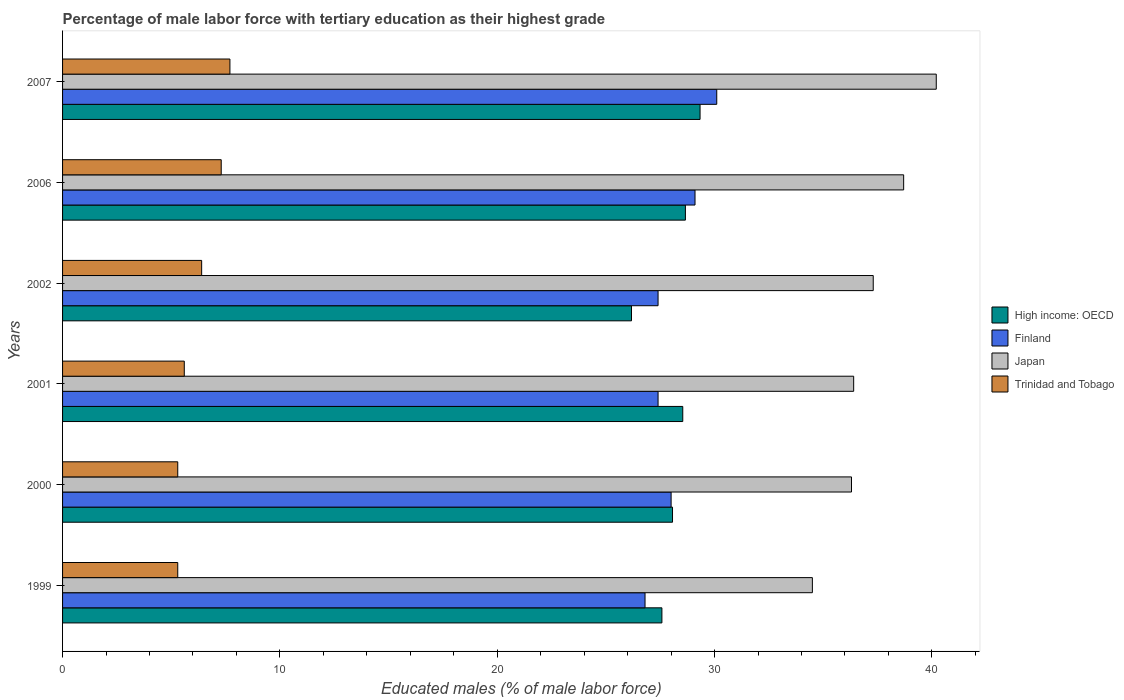How many different coloured bars are there?
Provide a succinct answer. 4. How many groups of bars are there?
Your answer should be very brief. 6. Are the number of bars per tick equal to the number of legend labels?
Ensure brevity in your answer.  Yes. How many bars are there on the 2nd tick from the top?
Offer a terse response. 4. In how many cases, is the number of bars for a given year not equal to the number of legend labels?
Your answer should be very brief. 0. What is the percentage of male labor force with tertiary education in High income: OECD in 2007?
Your answer should be compact. 29.33. Across all years, what is the maximum percentage of male labor force with tertiary education in Finland?
Provide a succinct answer. 30.1. Across all years, what is the minimum percentage of male labor force with tertiary education in Finland?
Keep it short and to the point. 26.8. In which year was the percentage of male labor force with tertiary education in Trinidad and Tobago minimum?
Your answer should be very brief. 1999. What is the total percentage of male labor force with tertiary education in Finland in the graph?
Your answer should be compact. 168.8. What is the difference between the percentage of male labor force with tertiary education in Japan in 2007 and the percentage of male labor force with tertiary education in Trinidad and Tobago in 2002?
Provide a short and direct response. 33.8. What is the average percentage of male labor force with tertiary education in High income: OECD per year?
Ensure brevity in your answer.  28.06. In the year 2002, what is the difference between the percentage of male labor force with tertiary education in Trinidad and Tobago and percentage of male labor force with tertiary education in Finland?
Give a very brief answer. -21. What is the ratio of the percentage of male labor force with tertiary education in High income: OECD in 1999 to that in 2001?
Make the answer very short. 0.97. Is the difference between the percentage of male labor force with tertiary education in Trinidad and Tobago in 2000 and 2006 greater than the difference between the percentage of male labor force with tertiary education in Finland in 2000 and 2006?
Your answer should be very brief. No. What is the difference between the highest and the lowest percentage of male labor force with tertiary education in High income: OECD?
Your response must be concise. 3.15. In how many years, is the percentage of male labor force with tertiary education in Finland greater than the average percentage of male labor force with tertiary education in Finland taken over all years?
Your answer should be very brief. 2. Is it the case that in every year, the sum of the percentage of male labor force with tertiary education in Finland and percentage of male labor force with tertiary education in High income: OECD is greater than the sum of percentage of male labor force with tertiary education in Trinidad and Tobago and percentage of male labor force with tertiary education in Japan?
Offer a very short reply. No. What does the 4th bar from the top in 2000 represents?
Ensure brevity in your answer.  High income: OECD. How many bars are there?
Provide a short and direct response. 24. How many years are there in the graph?
Your response must be concise. 6. Does the graph contain grids?
Provide a succinct answer. No. What is the title of the graph?
Your answer should be compact. Percentage of male labor force with tertiary education as their highest grade. What is the label or title of the X-axis?
Offer a terse response. Educated males (% of male labor force). What is the label or title of the Y-axis?
Offer a terse response. Years. What is the Educated males (% of male labor force) in High income: OECD in 1999?
Provide a succinct answer. 27.58. What is the Educated males (% of male labor force) of Finland in 1999?
Provide a succinct answer. 26.8. What is the Educated males (% of male labor force) of Japan in 1999?
Offer a terse response. 34.5. What is the Educated males (% of male labor force) of Trinidad and Tobago in 1999?
Ensure brevity in your answer.  5.3. What is the Educated males (% of male labor force) in High income: OECD in 2000?
Offer a terse response. 28.06. What is the Educated males (% of male labor force) in Finland in 2000?
Give a very brief answer. 28. What is the Educated males (% of male labor force) in Japan in 2000?
Provide a succinct answer. 36.3. What is the Educated males (% of male labor force) of Trinidad and Tobago in 2000?
Offer a terse response. 5.3. What is the Educated males (% of male labor force) of High income: OECD in 2001?
Keep it short and to the point. 28.54. What is the Educated males (% of male labor force) in Finland in 2001?
Make the answer very short. 27.4. What is the Educated males (% of male labor force) in Japan in 2001?
Give a very brief answer. 36.4. What is the Educated males (% of male labor force) of Trinidad and Tobago in 2001?
Make the answer very short. 5.6. What is the Educated males (% of male labor force) in High income: OECD in 2002?
Provide a succinct answer. 26.18. What is the Educated males (% of male labor force) of Finland in 2002?
Your response must be concise. 27.4. What is the Educated males (% of male labor force) in Japan in 2002?
Make the answer very short. 37.3. What is the Educated males (% of male labor force) in Trinidad and Tobago in 2002?
Ensure brevity in your answer.  6.4. What is the Educated males (% of male labor force) of High income: OECD in 2006?
Provide a succinct answer. 28.66. What is the Educated males (% of male labor force) in Finland in 2006?
Your response must be concise. 29.1. What is the Educated males (% of male labor force) of Japan in 2006?
Your response must be concise. 38.7. What is the Educated males (% of male labor force) of Trinidad and Tobago in 2006?
Offer a very short reply. 7.3. What is the Educated males (% of male labor force) of High income: OECD in 2007?
Make the answer very short. 29.33. What is the Educated males (% of male labor force) of Finland in 2007?
Offer a terse response. 30.1. What is the Educated males (% of male labor force) of Japan in 2007?
Offer a very short reply. 40.2. What is the Educated males (% of male labor force) in Trinidad and Tobago in 2007?
Your answer should be very brief. 7.7. Across all years, what is the maximum Educated males (% of male labor force) of High income: OECD?
Your response must be concise. 29.33. Across all years, what is the maximum Educated males (% of male labor force) of Finland?
Provide a succinct answer. 30.1. Across all years, what is the maximum Educated males (% of male labor force) of Japan?
Make the answer very short. 40.2. Across all years, what is the maximum Educated males (% of male labor force) of Trinidad and Tobago?
Your answer should be compact. 7.7. Across all years, what is the minimum Educated males (% of male labor force) of High income: OECD?
Your response must be concise. 26.18. Across all years, what is the minimum Educated males (% of male labor force) of Finland?
Keep it short and to the point. 26.8. Across all years, what is the minimum Educated males (% of male labor force) in Japan?
Give a very brief answer. 34.5. Across all years, what is the minimum Educated males (% of male labor force) in Trinidad and Tobago?
Your answer should be very brief. 5.3. What is the total Educated males (% of male labor force) in High income: OECD in the graph?
Provide a succinct answer. 168.34. What is the total Educated males (% of male labor force) of Finland in the graph?
Make the answer very short. 168.8. What is the total Educated males (% of male labor force) of Japan in the graph?
Provide a short and direct response. 223.4. What is the total Educated males (% of male labor force) of Trinidad and Tobago in the graph?
Your answer should be very brief. 37.6. What is the difference between the Educated males (% of male labor force) in High income: OECD in 1999 and that in 2000?
Provide a short and direct response. -0.49. What is the difference between the Educated males (% of male labor force) of Finland in 1999 and that in 2000?
Give a very brief answer. -1.2. What is the difference between the Educated males (% of male labor force) in Japan in 1999 and that in 2000?
Your answer should be compact. -1.8. What is the difference between the Educated males (% of male labor force) in High income: OECD in 1999 and that in 2001?
Provide a short and direct response. -0.96. What is the difference between the Educated males (% of male labor force) in Japan in 1999 and that in 2001?
Offer a terse response. -1.9. What is the difference between the Educated males (% of male labor force) in Trinidad and Tobago in 1999 and that in 2001?
Ensure brevity in your answer.  -0.3. What is the difference between the Educated males (% of male labor force) in High income: OECD in 1999 and that in 2002?
Provide a short and direct response. 1.4. What is the difference between the Educated males (% of male labor force) in Japan in 1999 and that in 2002?
Offer a very short reply. -2.8. What is the difference between the Educated males (% of male labor force) of Trinidad and Tobago in 1999 and that in 2002?
Give a very brief answer. -1.1. What is the difference between the Educated males (% of male labor force) in High income: OECD in 1999 and that in 2006?
Your response must be concise. -1.08. What is the difference between the Educated males (% of male labor force) of Finland in 1999 and that in 2006?
Keep it short and to the point. -2.3. What is the difference between the Educated males (% of male labor force) in Japan in 1999 and that in 2006?
Ensure brevity in your answer.  -4.2. What is the difference between the Educated males (% of male labor force) of High income: OECD in 1999 and that in 2007?
Provide a succinct answer. -1.76. What is the difference between the Educated males (% of male labor force) in Finland in 1999 and that in 2007?
Provide a short and direct response. -3.3. What is the difference between the Educated males (% of male labor force) of Japan in 1999 and that in 2007?
Offer a very short reply. -5.7. What is the difference between the Educated males (% of male labor force) of Trinidad and Tobago in 1999 and that in 2007?
Make the answer very short. -2.4. What is the difference between the Educated males (% of male labor force) in High income: OECD in 2000 and that in 2001?
Give a very brief answer. -0.47. What is the difference between the Educated males (% of male labor force) of Finland in 2000 and that in 2001?
Your answer should be compact. 0.6. What is the difference between the Educated males (% of male labor force) in Japan in 2000 and that in 2001?
Offer a very short reply. -0.1. What is the difference between the Educated males (% of male labor force) in Trinidad and Tobago in 2000 and that in 2001?
Make the answer very short. -0.3. What is the difference between the Educated males (% of male labor force) in High income: OECD in 2000 and that in 2002?
Ensure brevity in your answer.  1.89. What is the difference between the Educated males (% of male labor force) in Japan in 2000 and that in 2002?
Your answer should be compact. -1. What is the difference between the Educated males (% of male labor force) in High income: OECD in 2000 and that in 2006?
Your response must be concise. -0.59. What is the difference between the Educated males (% of male labor force) in Finland in 2000 and that in 2006?
Your answer should be compact. -1.1. What is the difference between the Educated males (% of male labor force) in Japan in 2000 and that in 2006?
Offer a terse response. -2.4. What is the difference between the Educated males (% of male labor force) of Trinidad and Tobago in 2000 and that in 2006?
Make the answer very short. -2. What is the difference between the Educated males (% of male labor force) in High income: OECD in 2000 and that in 2007?
Your answer should be compact. -1.27. What is the difference between the Educated males (% of male labor force) in Trinidad and Tobago in 2000 and that in 2007?
Your answer should be very brief. -2.4. What is the difference between the Educated males (% of male labor force) of High income: OECD in 2001 and that in 2002?
Offer a very short reply. 2.36. What is the difference between the Educated males (% of male labor force) in Finland in 2001 and that in 2002?
Make the answer very short. 0. What is the difference between the Educated males (% of male labor force) of Trinidad and Tobago in 2001 and that in 2002?
Keep it short and to the point. -0.8. What is the difference between the Educated males (% of male labor force) in High income: OECD in 2001 and that in 2006?
Give a very brief answer. -0.12. What is the difference between the Educated males (% of male labor force) in Finland in 2001 and that in 2006?
Offer a very short reply. -1.7. What is the difference between the Educated males (% of male labor force) in Japan in 2001 and that in 2006?
Provide a succinct answer. -2.3. What is the difference between the Educated males (% of male labor force) of Trinidad and Tobago in 2001 and that in 2006?
Offer a very short reply. -1.7. What is the difference between the Educated males (% of male labor force) in High income: OECD in 2001 and that in 2007?
Keep it short and to the point. -0.8. What is the difference between the Educated males (% of male labor force) in Finland in 2001 and that in 2007?
Your answer should be compact. -2.7. What is the difference between the Educated males (% of male labor force) in Trinidad and Tobago in 2001 and that in 2007?
Provide a succinct answer. -2.1. What is the difference between the Educated males (% of male labor force) in High income: OECD in 2002 and that in 2006?
Offer a very short reply. -2.48. What is the difference between the Educated males (% of male labor force) in Finland in 2002 and that in 2006?
Your answer should be compact. -1.7. What is the difference between the Educated males (% of male labor force) of Japan in 2002 and that in 2006?
Give a very brief answer. -1.4. What is the difference between the Educated males (% of male labor force) of High income: OECD in 2002 and that in 2007?
Your answer should be compact. -3.15. What is the difference between the Educated males (% of male labor force) in Trinidad and Tobago in 2002 and that in 2007?
Provide a short and direct response. -1.3. What is the difference between the Educated males (% of male labor force) of High income: OECD in 2006 and that in 2007?
Give a very brief answer. -0.67. What is the difference between the Educated males (% of male labor force) in Japan in 2006 and that in 2007?
Your answer should be very brief. -1.5. What is the difference between the Educated males (% of male labor force) in High income: OECD in 1999 and the Educated males (% of male labor force) in Finland in 2000?
Keep it short and to the point. -0.42. What is the difference between the Educated males (% of male labor force) in High income: OECD in 1999 and the Educated males (% of male labor force) in Japan in 2000?
Provide a short and direct response. -8.72. What is the difference between the Educated males (% of male labor force) in High income: OECD in 1999 and the Educated males (% of male labor force) in Trinidad and Tobago in 2000?
Keep it short and to the point. 22.28. What is the difference between the Educated males (% of male labor force) of Finland in 1999 and the Educated males (% of male labor force) of Trinidad and Tobago in 2000?
Provide a short and direct response. 21.5. What is the difference between the Educated males (% of male labor force) of Japan in 1999 and the Educated males (% of male labor force) of Trinidad and Tobago in 2000?
Provide a short and direct response. 29.2. What is the difference between the Educated males (% of male labor force) in High income: OECD in 1999 and the Educated males (% of male labor force) in Finland in 2001?
Provide a short and direct response. 0.18. What is the difference between the Educated males (% of male labor force) in High income: OECD in 1999 and the Educated males (% of male labor force) in Japan in 2001?
Give a very brief answer. -8.82. What is the difference between the Educated males (% of male labor force) of High income: OECD in 1999 and the Educated males (% of male labor force) of Trinidad and Tobago in 2001?
Your answer should be very brief. 21.98. What is the difference between the Educated males (% of male labor force) of Finland in 1999 and the Educated males (% of male labor force) of Japan in 2001?
Provide a short and direct response. -9.6. What is the difference between the Educated males (% of male labor force) in Finland in 1999 and the Educated males (% of male labor force) in Trinidad and Tobago in 2001?
Ensure brevity in your answer.  21.2. What is the difference between the Educated males (% of male labor force) of Japan in 1999 and the Educated males (% of male labor force) of Trinidad and Tobago in 2001?
Give a very brief answer. 28.9. What is the difference between the Educated males (% of male labor force) of High income: OECD in 1999 and the Educated males (% of male labor force) of Finland in 2002?
Your answer should be compact. 0.18. What is the difference between the Educated males (% of male labor force) of High income: OECD in 1999 and the Educated males (% of male labor force) of Japan in 2002?
Your answer should be very brief. -9.72. What is the difference between the Educated males (% of male labor force) in High income: OECD in 1999 and the Educated males (% of male labor force) in Trinidad and Tobago in 2002?
Ensure brevity in your answer.  21.18. What is the difference between the Educated males (% of male labor force) of Finland in 1999 and the Educated males (% of male labor force) of Japan in 2002?
Give a very brief answer. -10.5. What is the difference between the Educated males (% of male labor force) of Finland in 1999 and the Educated males (% of male labor force) of Trinidad and Tobago in 2002?
Provide a short and direct response. 20.4. What is the difference between the Educated males (% of male labor force) of Japan in 1999 and the Educated males (% of male labor force) of Trinidad and Tobago in 2002?
Provide a short and direct response. 28.1. What is the difference between the Educated males (% of male labor force) of High income: OECD in 1999 and the Educated males (% of male labor force) of Finland in 2006?
Offer a very short reply. -1.52. What is the difference between the Educated males (% of male labor force) of High income: OECD in 1999 and the Educated males (% of male labor force) of Japan in 2006?
Your response must be concise. -11.12. What is the difference between the Educated males (% of male labor force) in High income: OECD in 1999 and the Educated males (% of male labor force) in Trinidad and Tobago in 2006?
Provide a succinct answer. 20.28. What is the difference between the Educated males (% of male labor force) in Finland in 1999 and the Educated males (% of male labor force) in Japan in 2006?
Provide a short and direct response. -11.9. What is the difference between the Educated males (% of male labor force) of Japan in 1999 and the Educated males (% of male labor force) of Trinidad and Tobago in 2006?
Your answer should be compact. 27.2. What is the difference between the Educated males (% of male labor force) in High income: OECD in 1999 and the Educated males (% of male labor force) in Finland in 2007?
Keep it short and to the point. -2.52. What is the difference between the Educated males (% of male labor force) of High income: OECD in 1999 and the Educated males (% of male labor force) of Japan in 2007?
Keep it short and to the point. -12.62. What is the difference between the Educated males (% of male labor force) in High income: OECD in 1999 and the Educated males (% of male labor force) in Trinidad and Tobago in 2007?
Provide a succinct answer. 19.88. What is the difference between the Educated males (% of male labor force) in Finland in 1999 and the Educated males (% of male labor force) in Japan in 2007?
Offer a terse response. -13.4. What is the difference between the Educated males (% of male labor force) in Finland in 1999 and the Educated males (% of male labor force) in Trinidad and Tobago in 2007?
Give a very brief answer. 19.1. What is the difference between the Educated males (% of male labor force) in Japan in 1999 and the Educated males (% of male labor force) in Trinidad and Tobago in 2007?
Ensure brevity in your answer.  26.8. What is the difference between the Educated males (% of male labor force) of High income: OECD in 2000 and the Educated males (% of male labor force) of Finland in 2001?
Keep it short and to the point. 0.66. What is the difference between the Educated males (% of male labor force) in High income: OECD in 2000 and the Educated males (% of male labor force) in Japan in 2001?
Provide a succinct answer. -8.34. What is the difference between the Educated males (% of male labor force) in High income: OECD in 2000 and the Educated males (% of male labor force) in Trinidad and Tobago in 2001?
Offer a very short reply. 22.46. What is the difference between the Educated males (% of male labor force) in Finland in 2000 and the Educated males (% of male labor force) in Japan in 2001?
Give a very brief answer. -8.4. What is the difference between the Educated males (% of male labor force) of Finland in 2000 and the Educated males (% of male labor force) of Trinidad and Tobago in 2001?
Your answer should be very brief. 22.4. What is the difference between the Educated males (% of male labor force) of Japan in 2000 and the Educated males (% of male labor force) of Trinidad and Tobago in 2001?
Make the answer very short. 30.7. What is the difference between the Educated males (% of male labor force) of High income: OECD in 2000 and the Educated males (% of male labor force) of Finland in 2002?
Keep it short and to the point. 0.66. What is the difference between the Educated males (% of male labor force) of High income: OECD in 2000 and the Educated males (% of male labor force) of Japan in 2002?
Offer a very short reply. -9.24. What is the difference between the Educated males (% of male labor force) in High income: OECD in 2000 and the Educated males (% of male labor force) in Trinidad and Tobago in 2002?
Give a very brief answer. 21.66. What is the difference between the Educated males (% of male labor force) of Finland in 2000 and the Educated males (% of male labor force) of Japan in 2002?
Make the answer very short. -9.3. What is the difference between the Educated males (% of male labor force) in Finland in 2000 and the Educated males (% of male labor force) in Trinidad and Tobago in 2002?
Your response must be concise. 21.6. What is the difference between the Educated males (% of male labor force) in Japan in 2000 and the Educated males (% of male labor force) in Trinidad and Tobago in 2002?
Your response must be concise. 29.9. What is the difference between the Educated males (% of male labor force) in High income: OECD in 2000 and the Educated males (% of male labor force) in Finland in 2006?
Give a very brief answer. -1.04. What is the difference between the Educated males (% of male labor force) of High income: OECD in 2000 and the Educated males (% of male labor force) of Japan in 2006?
Offer a terse response. -10.64. What is the difference between the Educated males (% of male labor force) in High income: OECD in 2000 and the Educated males (% of male labor force) in Trinidad and Tobago in 2006?
Offer a terse response. 20.76. What is the difference between the Educated males (% of male labor force) of Finland in 2000 and the Educated males (% of male labor force) of Japan in 2006?
Make the answer very short. -10.7. What is the difference between the Educated males (% of male labor force) of Finland in 2000 and the Educated males (% of male labor force) of Trinidad and Tobago in 2006?
Give a very brief answer. 20.7. What is the difference between the Educated males (% of male labor force) of High income: OECD in 2000 and the Educated males (% of male labor force) of Finland in 2007?
Your answer should be very brief. -2.04. What is the difference between the Educated males (% of male labor force) of High income: OECD in 2000 and the Educated males (% of male labor force) of Japan in 2007?
Offer a terse response. -12.14. What is the difference between the Educated males (% of male labor force) of High income: OECD in 2000 and the Educated males (% of male labor force) of Trinidad and Tobago in 2007?
Keep it short and to the point. 20.36. What is the difference between the Educated males (% of male labor force) in Finland in 2000 and the Educated males (% of male labor force) in Japan in 2007?
Your response must be concise. -12.2. What is the difference between the Educated males (% of male labor force) in Finland in 2000 and the Educated males (% of male labor force) in Trinidad and Tobago in 2007?
Your answer should be very brief. 20.3. What is the difference between the Educated males (% of male labor force) in Japan in 2000 and the Educated males (% of male labor force) in Trinidad and Tobago in 2007?
Your answer should be very brief. 28.6. What is the difference between the Educated males (% of male labor force) of High income: OECD in 2001 and the Educated males (% of male labor force) of Finland in 2002?
Give a very brief answer. 1.14. What is the difference between the Educated males (% of male labor force) of High income: OECD in 2001 and the Educated males (% of male labor force) of Japan in 2002?
Make the answer very short. -8.76. What is the difference between the Educated males (% of male labor force) of High income: OECD in 2001 and the Educated males (% of male labor force) of Trinidad and Tobago in 2002?
Your response must be concise. 22.14. What is the difference between the Educated males (% of male labor force) of Finland in 2001 and the Educated males (% of male labor force) of Trinidad and Tobago in 2002?
Make the answer very short. 21. What is the difference between the Educated males (% of male labor force) of Japan in 2001 and the Educated males (% of male labor force) of Trinidad and Tobago in 2002?
Ensure brevity in your answer.  30. What is the difference between the Educated males (% of male labor force) in High income: OECD in 2001 and the Educated males (% of male labor force) in Finland in 2006?
Give a very brief answer. -0.56. What is the difference between the Educated males (% of male labor force) of High income: OECD in 2001 and the Educated males (% of male labor force) of Japan in 2006?
Ensure brevity in your answer.  -10.16. What is the difference between the Educated males (% of male labor force) in High income: OECD in 2001 and the Educated males (% of male labor force) in Trinidad and Tobago in 2006?
Give a very brief answer. 21.24. What is the difference between the Educated males (% of male labor force) of Finland in 2001 and the Educated males (% of male labor force) of Japan in 2006?
Give a very brief answer. -11.3. What is the difference between the Educated males (% of male labor force) of Finland in 2001 and the Educated males (% of male labor force) of Trinidad and Tobago in 2006?
Provide a short and direct response. 20.1. What is the difference between the Educated males (% of male labor force) of Japan in 2001 and the Educated males (% of male labor force) of Trinidad and Tobago in 2006?
Provide a succinct answer. 29.1. What is the difference between the Educated males (% of male labor force) of High income: OECD in 2001 and the Educated males (% of male labor force) of Finland in 2007?
Provide a short and direct response. -1.56. What is the difference between the Educated males (% of male labor force) in High income: OECD in 2001 and the Educated males (% of male labor force) in Japan in 2007?
Make the answer very short. -11.66. What is the difference between the Educated males (% of male labor force) in High income: OECD in 2001 and the Educated males (% of male labor force) in Trinidad and Tobago in 2007?
Offer a terse response. 20.84. What is the difference between the Educated males (% of male labor force) of Finland in 2001 and the Educated males (% of male labor force) of Japan in 2007?
Offer a terse response. -12.8. What is the difference between the Educated males (% of male labor force) of Japan in 2001 and the Educated males (% of male labor force) of Trinidad and Tobago in 2007?
Your response must be concise. 28.7. What is the difference between the Educated males (% of male labor force) of High income: OECD in 2002 and the Educated males (% of male labor force) of Finland in 2006?
Make the answer very short. -2.92. What is the difference between the Educated males (% of male labor force) in High income: OECD in 2002 and the Educated males (% of male labor force) in Japan in 2006?
Provide a succinct answer. -12.52. What is the difference between the Educated males (% of male labor force) of High income: OECD in 2002 and the Educated males (% of male labor force) of Trinidad and Tobago in 2006?
Make the answer very short. 18.88. What is the difference between the Educated males (% of male labor force) in Finland in 2002 and the Educated males (% of male labor force) in Japan in 2006?
Make the answer very short. -11.3. What is the difference between the Educated males (% of male labor force) of Finland in 2002 and the Educated males (% of male labor force) of Trinidad and Tobago in 2006?
Offer a very short reply. 20.1. What is the difference between the Educated males (% of male labor force) in High income: OECD in 2002 and the Educated males (% of male labor force) in Finland in 2007?
Make the answer very short. -3.92. What is the difference between the Educated males (% of male labor force) in High income: OECD in 2002 and the Educated males (% of male labor force) in Japan in 2007?
Keep it short and to the point. -14.02. What is the difference between the Educated males (% of male labor force) in High income: OECD in 2002 and the Educated males (% of male labor force) in Trinidad and Tobago in 2007?
Your answer should be very brief. 18.48. What is the difference between the Educated males (% of male labor force) of Finland in 2002 and the Educated males (% of male labor force) of Trinidad and Tobago in 2007?
Make the answer very short. 19.7. What is the difference between the Educated males (% of male labor force) in Japan in 2002 and the Educated males (% of male labor force) in Trinidad and Tobago in 2007?
Provide a short and direct response. 29.6. What is the difference between the Educated males (% of male labor force) of High income: OECD in 2006 and the Educated males (% of male labor force) of Finland in 2007?
Your response must be concise. -1.44. What is the difference between the Educated males (% of male labor force) of High income: OECD in 2006 and the Educated males (% of male labor force) of Japan in 2007?
Offer a terse response. -11.54. What is the difference between the Educated males (% of male labor force) of High income: OECD in 2006 and the Educated males (% of male labor force) of Trinidad and Tobago in 2007?
Make the answer very short. 20.96. What is the difference between the Educated males (% of male labor force) in Finland in 2006 and the Educated males (% of male labor force) in Trinidad and Tobago in 2007?
Provide a short and direct response. 21.4. What is the average Educated males (% of male labor force) of High income: OECD per year?
Make the answer very short. 28.06. What is the average Educated males (% of male labor force) in Finland per year?
Provide a short and direct response. 28.13. What is the average Educated males (% of male labor force) in Japan per year?
Offer a terse response. 37.23. What is the average Educated males (% of male labor force) in Trinidad and Tobago per year?
Your answer should be compact. 6.27. In the year 1999, what is the difference between the Educated males (% of male labor force) of High income: OECD and Educated males (% of male labor force) of Finland?
Offer a terse response. 0.78. In the year 1999, what is the difference between the Educated males (% of male labor force) in High income: OECD and Educated males (% of male labor force) in Japan?
Provide a succinct answer. -6.92. In the year 1999, what is the difference between the Educated males (% of male labor force) of High income: OECD and Educated males (% of male labor force) of Trinidad and Tobago?
Offer a very short reply. 22.28. In the year 1999, what is the difference between the Educated males (% of male labor force) of Finland and Educated males (% of male labor force) of Japan?
Your answer should be very brief. -7.7. In the year 1999, what is the difference between the Educated males (% of male labor force) in Finland and Educated males (% of male labor force) in Trinidad and Tobago?
Your answer should be very brief. 21.5. In the year 1999, what is the difference between the Educated males (% of male labor force) of Japan and Educated males (% of male labor force) of Trinidad and Tobago?
Provide a short and direct response. 29.2. In the year 2000, what is the difference between the Educated males (% of male labor force) of High income: OECD and Educated males (% of male labor force) of Finland?
Give a very brief answer. 0.06. In the year 2000, what is the difference between the Educated males (% of male labor force) of High income: OECD and Educated males (% of male labor force) of Japan?
Offer a very short reply. -8.24. In the year 2000, what is the difference between the Educated males (% of male labor force) in High income: OECD and Educated males (% of male labor force) in Trinidad and Tobago?
Keep it short and to the point. 22.76. In the year 2000, what is the difference between the Educated males (% of male labor force) in Finland and Educated males (% of male labor force) in Trinidad and Tobago?
Offer a very short reply. 22.7. In the year 2001, what is the difference between the Educated males (% of male labor force) in High income: OECD and Educated males (% of male labor force) in Finland?
Give a very brief answer. 1.14. In the year 2001, what is the difference between the Educated males (% of male labor force) of High income: OECD and Educated males (% of male labor force) of Japan?
Keep it short and to the point. -7.86. In the year 2001, what is the difference between the Educated males (% of male labor force) of High income: OECD and Educated males (% of male labor force) of Trinidad and Tobago?
Keep it short and to the point. 22.94. In the year 2001, what is the difference between the Educated males (% of male labor force) in Finland and Educated males (% of male labor force) in Trinidad and Tobago?
Offer a very short reply. 21.8. In the year 2001, what is the difference between the Educated males (% of male labor force) in Japan and Educated males (% of male labor force) in Trinidad and Tobago?
Make the answer very short. 30.8. In the year 2002, what is the difference between the Educated males (% of male labor force) in High income: OECD and Educated males (% of male labor force) in Finland?
Make the answer very short. -1.22. In the year 2002, what is the difference between the Educated males (% of male labor force) of High income: OECD and Educated males (% of male labor force) of Japan?
Provide a short and direct response. -11.12. In the year 2002, what is the difference between the Educated males (% of male labor force) in High income: OECD and Educated males (% of male labor force) in Trinidad and Tobago?
Provide a short and direct response. 19.78. In the year 2002, what is the difference between the Educated males (% of male labor force) in Finland and Educated males (% of male labor force) in Trinidad and Tobago?
Your answer should be compact. 21. In the year 2002, what is the difference between the Educated males (% of male labor force) in Japan and Educated males (% of male labor force) in Trinidad and Tobago?
Give a very brief answer. 30.9. In the year 2006, what is the difference between the Educated males (% of male labor force) in High income: OECD and Educated males (% of male labor force) in Finland?
Your answer should be very brief. -0.44. In the year 2006, what is the difference between the Educated males (% of male labor force) of High income: OECD and Educated males (% of male labor force) of Japan?
Provide a short and direct response. -10.04. In the year 2006, what is the difference between the Educated males (% of male labor force) of High income: OECD and Educated males (% of male labor force) of Trinidad and Tobago?
Your response must be concise. 21.36. In the year 2006, what is the difference between the Educated males (% of male labor force) of Finland and Educated males (% of male labor force) of Trinidad and Tobago?
Provide a short and direct response. 21.8. In the year 2006, what is the difference between the Educated males (% of male labor force) in Japan and Educated males (% of male labor force) in Trinidad and Tobago?
Your answer should be compact. 31.4. In the year 2007, what is the difference between the Educated males (% of male labor force) in High income: OECD and Educated males (% of male labor force) in Finland?
Your response must be concise. -0.77. In the year 2007, what is the difference between the Educated males (% of male labor force) in High income: OECD and Educated males (% of male labor force) in Japan?
Your answer should be very brief. -10.87. In the year 2007, what is the difference between the Educated males (% of male labor force) of High income: OECD and Educated males (% of male labor force) of Trinidad and Tobago?
Provide a succinct answer. 21.63. In the year 2007, what is the difference between the Educated males (% of male labor force) of Finland and Educated males (% of male labor force) of Trinidad and Tobago?
Provide a short and direct response. 22.4. In the year 2007, what is the difference between the Educated males (% of male labor force) in Japan and Educated males (% of male labor force) in Trinidad and Tobago?
Provide a succinct answer. 32.5. What is the ratio of the Educated males (% of male labor force) in High income: OECD in 1999 to that in 2000?
Ensure brevity in your answer.  0.98. What is the ratio of the Educated males (% of male labor force) in Finland in 1999 to that in 2000?
Offer a very short reply. 0.96. What is the ratio of the Educated males (% of male labor force) of Japan in 1999 to that in 2000?
Make the answer very short. 0.95. What is the ratio of the Educated males (% of male labor force) of Trinidad and Tobago in 1999 to that in 2000?
Offer a terse response. 1. What is the ratio of the Educated males (% of male labor force) in High income: OECD in 1999 to that in 2001?
Offer a very short reply. 0.97. What is the ratio of the Educated males (% of male labor force) of Finland in 1999 to that in 2001?
Keep it short and to the point. 0.98. What is the ratio of the Educated males (% of male labor force) in Japan in 1999 to that in 2001?
Make the answer very short. 0.95. What is the ratio of the Educated males (% of male labor force) in Trinidad and Tobago in 1999 to that in 2001?
Make the answer very short. 0.95. What is the ratio of the Educated males (% of male labor force) in High income: OECD in 1999 to that in 2002?
Your answer should be compact. 1.05. What is the ratio of the Educated males (% of male labor force) of Finland in 1999 to that in 2002?
Offer a very short reply. 0.98. What is the ratio of the Educated males (% of male labor force) of Japan in 1999 to that in 2002?
Your response must be concise. 0.92. What is the ratio of the Educated males (% of male labor force) in Trinidad and Tobago in 1999 to that in 2002?
Make the answer very short. 0.83. What is the ratio of the Educated males (% of male labor force) in High income: OECD in 1999 to that in 2006?
Offer a terse response. 0.96. What is the ratio of the Educated males (% of male labor force) of Finland in 1999 to that in 2006?
Provide a short and direct response. 0.92. What is the ratio of the Educated males (% of male labor force) of Japan in 1999 to that in 2006?
Offer a very short reply. 0.89. What is the ratio of the Educated males (% of male labor force) of Trinidad and Tobago in 1999 to that in 2006?
Your answer should be very brief. 0.73. What is the ratio of the Educated males (% of male labor force) of High income: OECD in 1999 to that in 2007?
Give a very brief answer. 0.94. What is the ratio of the Educated males (% of male labor force) of Finland in 1999 to that in 2007?
Give a very brief answer. 0.89. What is the ratio of the Educated males (% of male labor force) in Japan in 1999 to that in 2007?
Give a very brief answer. 0.86. What is the ratio of the Educated males (% of male labor force) of Trinidad and Tobago in 1999 to that in 2007?
Ensure brevity in your answer.  0.69. What is the ratio of the Educated males (% of male labor force) of High income: OECD in 2000 to that in 2001?
Provide a short and direct response. 0.98. What is the ratio of the Educated males (% of male labor force) in Finland in 2000 to that in 2001?
Make the answer very short. 1.02. What is the ratio of the Educated males (% of male labor force) of Japan in 2000 to that in 2001?
Offer a terse response. 1. What is the ratio of the Educated males (% of male labor force) of Trinidad and Tobago in 2000 to that in 2001?
Your answer should be very brief. 0.95. What is the ratio of the Educated males (% of male labor force) of High income: OECD in 2000 to that in 2002?
Provide a succinct answer. 1.07. What is the ratio of the Educated males (% of male labor force) of Finland in 2000 to that in 2002?
Your answer should be very brief. 1.02. What is the ratio of the Educated males (% of male labor force) of Japan in 2000 to that in 2002?
Keep it short and to the point. 0.97. What is the ratio of the Educated males (% of male labor force) in Trinidad and Tobago in 2000 to that in 2002?
Offer a very short reply. 0.83. What is the ratio of the Educated males (% of male labor force) of High income: OECD in 2000 to that in 2006?
Keep it short and to the point. 0.98. What is the ratio of the Educated males (% of male labor force) in Finland in 2000 to that in 2006?
Your answer should be compact. 0.96. What is the ratio of the Educated males (% of male labor force) of Japan in 2000 to that in 2006?
Keep it short and to the point. 0.94. What is the ratio of the Educated males (% of male labor force) of Trinidad and Tobago in 2000 to that in 2006?
Provide a short and direct response. 0.73. What is the ratio of the Educated males (% of male labor force) of High income: OECD in 2000 to that in 2007?
Your answer should be very brief. 0.96. What is the ratio of the Educated males (% of male labor force) in Finland in 2000 to that in 2007?
Your response must be concise. 0.93. What is the ratio of the Educated males (% of male labor force) in Japan in 2000 to that in 2007?
Provide a succinct answer. 0.9. What is the ratio of the Educated males (% of male labor force) in Trinidad and Tobago in 2000 to that in 2007?
Your answer should be compact. 0.69. What is the ratio of the Educated males (% of male labor force) in High income: OECD in 2001 to that in 2002?
Your answer should be very brief. 1.09. What is the ratio of the Educated males (% of male labor force) in Finland in 2001 to that in 2002?
Ensure brevity in your answer.  1. What is the ratio of the Educated males (% of male labor force) in Japan in 2001 to that in 2002?
Your answer should be compact. 0.98. What is the ratio of the Educated males (% of male labor force) of High income: OECD in 2001 to that in 2006?
Offer a terse response. 1. What is the ratio of the Educated males (% of male labor force) in Finland in 2001 to that in 2006?
Offer a very short reply. 0.94. What is the ratio of the Educated males (% of male labor force) in Japan in 2001 to that in 2006?
Keep it short and to the point. 0.94. What is the ratio of the Educated males (% of male labor force) of Trinidad and Tobago in 2001 to that in 2006?
Offer a very short reply. 0.77. What is the ratio of the Educated males (% of male labor force) of High income: OECD in 2001 to that in 2007?
Offer a very short reply. 0.97. What is the ratio of the Educated males (% of male labor force) of Finland in 2001 to that in 2007?
Provide a short and direct response. 0.91. What is the ratio of the Educated males (% of male labor force) in Japan in 2001 to that in 2007?
Your answer should be compact. 0.91. What is the ratio of the Educated males (% of male labor force) in Trinidad and Tobago in 2001 to that in 2007?
Ensure brevity in your answer.  0.73. What is the ratio of the Educated males (% of male labor force) in High income: OECD in 2002 to that in 2006?
Give a very brief answer. 0.91. What is the ratio of the Educated males (% of male labor force) in Finland in 2002 to that in 2006?
Your answer should be compact. 0.94. What is the ratio of the Educated males (% of male labor force) of Japan in 2002 to that in 2006?
Your answer should be compact. 0.96. What is the ratio of the Educated males (% of male labor force) of Trinidad and Tobago in 2002 to that in 2006?
Offer a very short reply. 0.88. What is the ratio of the Educated males (% of male labor force) in High income: OECD in 2002 to that in 2007?
Provide a short and direct response. 0.89. What is the ratio of the Educated males (% of male labor force) in Finland in 2002 to that in 2007?
Offer a terse response. 0.91. What is the ratio of the Educated males (% of male labor force) of Japan in 2002 to that in 2007?
Provide a short and direct response. 0.93. What is the ratio of the Educated males (% of male labor force) in Trinidad and Tobago in 2002 to that in 2007?
Your answer should be very brief. 0.83. What is the ratio of the Educated males (% of male labor force) in Finland in 2006 to that in 2007?
Provide a succinct answer. 0.97. What is the ratio of the Educated males (% of male labor force) of Japan in 2006 to that in 2007?
Give a very brief answer. 0.96. What is the ratio of the Educated males (% of male labor force) of Trinidad and Tobago in 2006 to that in 2007?
Keep it short and to the point. 0.95. What is the difference between the highest and the second highest Educated males (% of male labor force) of High income: OECD?
Provide a short and direct response. 0.67. What is the difference between the highest and the second highest Educated males (% of male labor force) in Japan?
Your answer should be compact. 1.5. What is the difference between the highest and the lowest Educated males (% of male labor force) in High income: OECD?
Give a very brief answer. 3.15. What is the difference between the highest and the lowest Educated males (% of male labor force) of Finland?
Your answer should be compact. 3.3. 